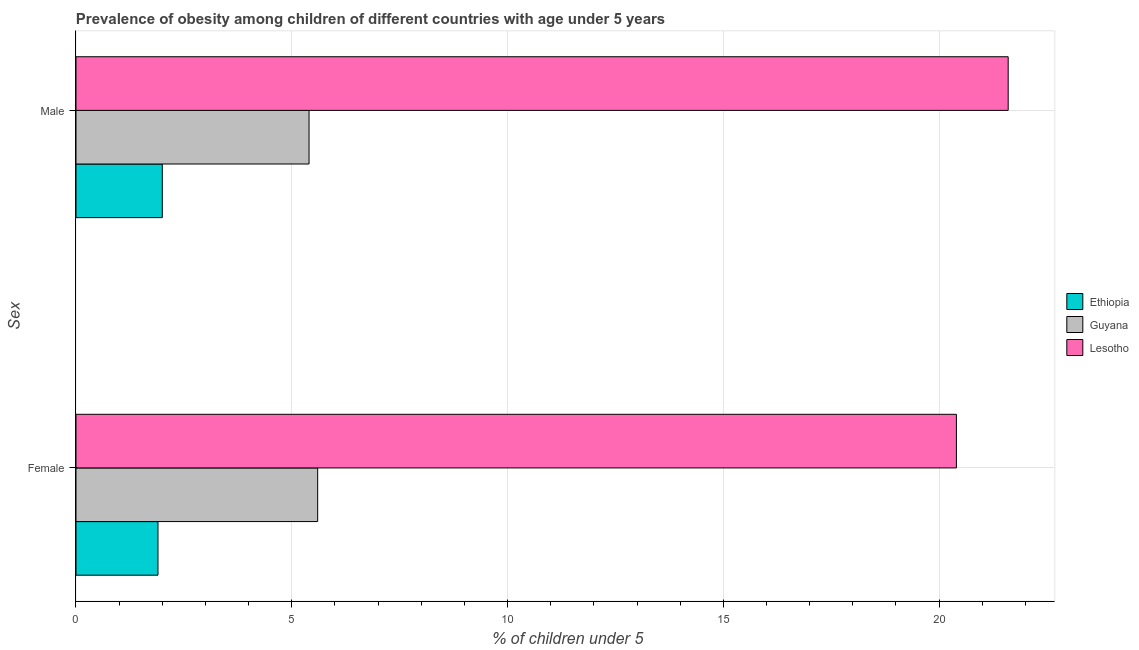How many different coloured bars are there?
Your answer should be very brief. 3. How many groups of bars are there?
Offer a terse response. 2. How many bars are there on the 1st tick from the top?
Offer a very short reply. 3. How many bars are there on the 2nd tick from the bottom?
Your response must be concise. 3. What is the percentage of obese female children in Lesotho?
Ensure brevity in your answer.  20.4. Across all countries, what is the maximum percentage of obese female children?
Give a very brief answer. 20.4. In which country was the percentage of obese male children maximum?
Your response must be concise. Lesotho. In which country was the percentage of obese female children minimum?
Your answer should be very brief. Ethiopia. What is the total percentage of obese female children in the graph?
Keep it short and to the point. 27.9. What is the difference between the percentage of obese male children in Guyana and that in Ethiopia?
Provide a succinct answer. 3.4. What is the difference between the percentage of obese female children in Ethiopia and the percentage of obese male children in Lesotho?
Make the answer very short. -19.7. What is the average percentage of obese female children per country?
Offer a very short reply. 9.3. What is the difference between the percentage of obese female children and percentage of obese male children in Lesotho?
Offer a very short reply. -1.2. In how many countries, is the percentage of obese male children greater than 17 %?
Provide a succinct answer. 1. What is the ratio of the percentage of obese female children in Guyana to that in Ethiopia?
Give a very brief answer. 2.95. Is the percentage of obese female children in Lesotho less than that in Ethiopia?
Give a very brief answer. No. In how many countries, is the percentage of obese female children greater than the average percentage of obese female children taken over all countries?
Keep it short and to the point. 1. What does the 3rd bar from the top in Male represents?
Give a very brief answer. Ethiopia. What does the 3rd bar from the bottom in Male represents?
Your answer should be compact. Lesotho. How many bars are there?
Ensure brevity in your answer.  6. Are all the bars in the graph horizontal?
Ensure brevity in your answer.  Yes. How many countries are there in the graph?
Keep it short and to the point. 3. What is the difference between two consecutive major ticks on the X-axis?
Give a very brief answer. 5. Does the graph contain any zero values?
Make the answer very short. No. Does the graph contain grids?
Your response must be concise. Yes. Where does the legend appear in the graph?
Offer a terse response. Center right. How many legend labels are there?
Keep it short and to the point. 3. What is the title of the graph?
Give a very brief answer. Prevalence of obesity among children of different countries with age under 5 years. What is the label or title of the X-axis?
Make the answer very short.  % of children under 5. What is the label or title of the Y-axis?
Make the answer very short. Sex. What is the  % of children under 5 in Ethiopia in Female?
Your answer should be very brief. 1.9. What is the  % of children under 5 in Guyana in Female?
Your answer should be compact. 5.6. What is the  % of children under 5 in Lesotho in Female?
Provide a succinct answer. 20.4. What is the  % of children under 5 of Ethiopia in Male?
Provide a succinct answer. 2. What is the  % of children under 5 in Guyana in Male?
Offer a very short reply. 5.4. What is the  % of children under 5 in Lesotho in Male?
Offer a very short reply. 21.6. Across all Sex, what is the maximum  % of children under 5 of Ethiopia?
Make the answer very short. 2. Across all Sex, what is the maximum  % of children under 5 in Guyana?
Offer a terse response. 5.6. Across all Sex, what is the maximum  % of children under 5 in Lesotho?
Make the answer very short. 21.6. Across all Sex, what is the minimum  % of children under 5 of Ethiopia?
Make the answer very short. 1.9. Across all Sex, what is the minimum  % of children under 5 in Guyana?
Your answer should be very brief. 5.4. Across all Sex, what is the minimum  % of children under 5 of Lesotho?
Your answer should be compact. 20.4. What is the total  % of children under 5 of Ethiopia in the graph?
Offer a terse response. 3.9. What is the total  % of children under 5 of Guyana in the graph?
Make the answer very short. 11. What is the total  % of children under 5 of Lesotho in the graph?
Make the answer very short. 42. What is the difference between the  % of children under 5 in Ethiopia in Female and that in Male?
Provide a short and direct response. -0.1. What is the difference between the  % of children under 5 of Guyana in Female and that in Male?
Make the answer very short. 0.2. What is the difference between the  % of children under 5 of Lesotho in Female and that in Male?
Keep it short and to the point. -1.2. What is the difference between the  % of children under 5 in Ethiopia in Female and the  % of children under 5 in Guyana in Male?
Your answer should be compact. -3.5. What is the difference between the  % of children under 5 of Ethiopia in Female and the  % of children under 5 of Lesotho in Male?
Keep it short and to the point. -19.7. What is the difference between the  % of children under 5 of Guyana in Female and the  % of children under 5 of Lesotho in Male?
Your answer should be compact. -16. What is the average  % of children under 5 in Ethiopia per Sex?
Make the answer very short. 1.95. What is the average  % of children under 5 of Guyana per Sex?
Keep it short and to the point. 5.5. What is the average  % of children under 5 in Lesotho per Sex?
Provide a succinct answer. 21. What is the difference between the  % of children under 5 of Ethiopia and  % of children under 5 of Guyana in Female?
Provide a succinct answer. -3.7. What is the difference between the  % of children under 5 of Ethiopia and  % of children under 5 of Lesotho in Female?
Provide a succinct answer. -18.5. What is the difference between the  % of children under 5 of Guyana and  % of children under 5 of Lesotho in Female?
Your response must be concise. -14.8. What is the difference between the  % of children under 5 in Ethiopia and  % of children under 5 in Guyana in Male?
Keep it short and to the point. -3.4. What is the difference between the  % of children under 5 in Ethiopia and  % of children under 5 in Lesotho in Male?
Your response must be concise. -19.6. What is the difference between the  % of children under 5 in Guyana and  % of children under 5 in Lesotho in Male?
Your response must be concise. -16.2. What is the ratio of the  % of children under 5 of Ethiopia in Female to that in Male?
Ensure brevity in your answer.  0.95. What is the ratio of the  % of children under 5 in Guyana in Female to that in Male?
Offer a terse response. 1.04. What is the ratio of the  % of children under 5 in Lesotho in Female to that in Male?
Your answer should be compact. 0.94. What is the difference between the highest and the second highest  % of children under 5 in Ethiopia?
Your answer should be very brief. 0.1. What is the difference between the highest and the lowest  % of children under 5 of Ethiopia?
Offer a terse response. 0.1. 